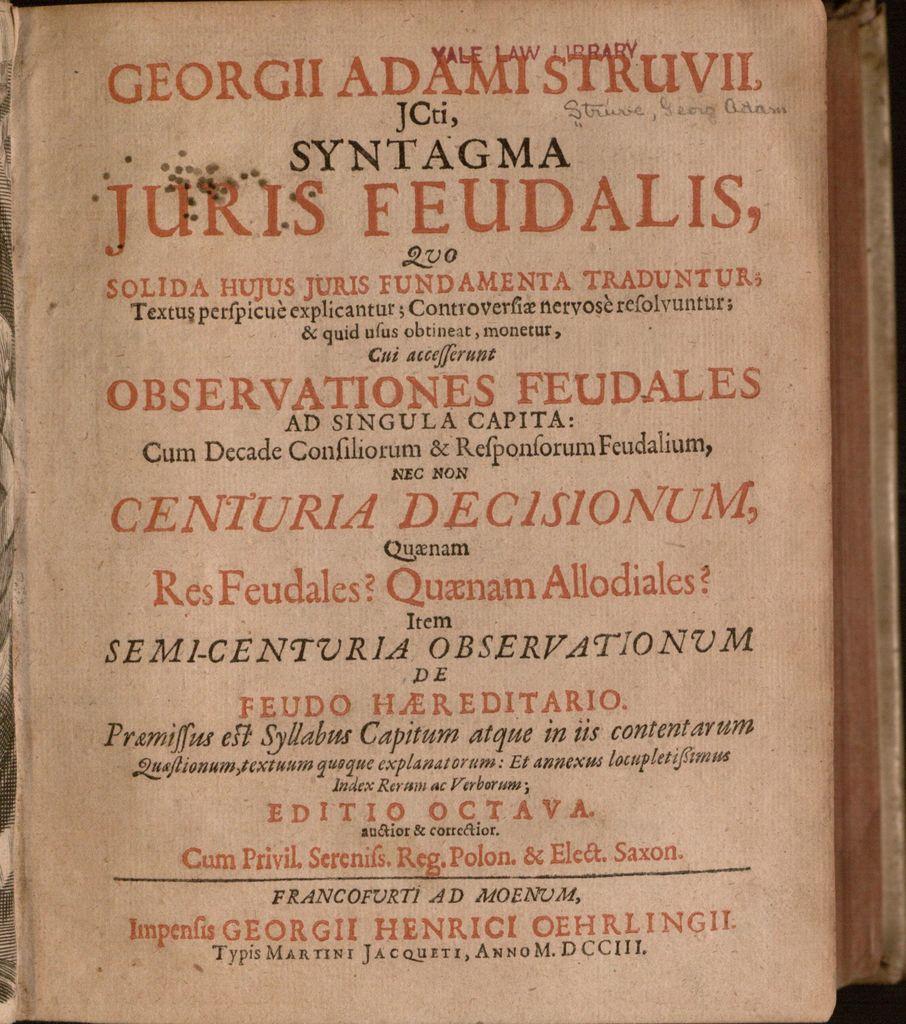What is the last name of juris?
Offer a terse response. Feudalis. What law school is this from?
Give a very brief answer. Yale. 